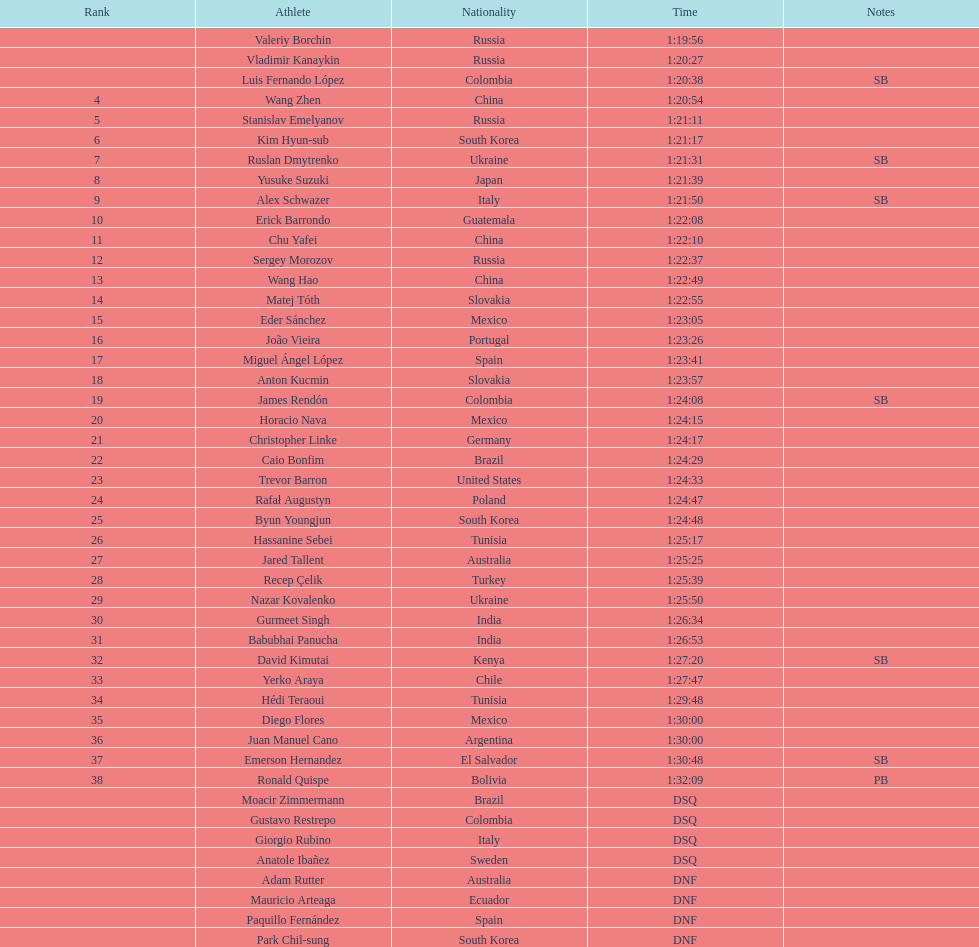What is the number of japanese in the top 10? 1. 